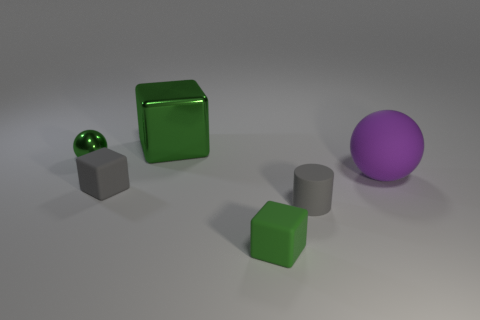How many other things are there of the same color as the small shiny thing?
Your answer should be very brief. 2. Is the color of the large metal thing the same as the tiny matte cylinder?
Your answer should be very brief. No. There is a rubber thing that is both in front of the gray rubber cube and on the right side of the small green rubber thing; what is its color?
Provide a succinct answer. Gray. There is a big purple sphere; are there any tiny gray rubber things left of it?
Provide a succinct answer. Yes. There is a green cube that is in front of the metal block; how many small green cubes are right of it?
Give a very brief answer. 0. There is a green ball that is made of the same material as the big block; what size is it?
Provide a succinct answer. Small. The gray block has what size?
Keep it short and to the point. Small. Do the purple thing and the small green sphere have the same material?
Your response must be concise. No. How many cubes are green objects or small green rubber things?
Provide a short and direct response. 2. What is the color of the tiny matte cube behind the green object in front of the big purple rubber object?
Offer a very short reply. Gray. 